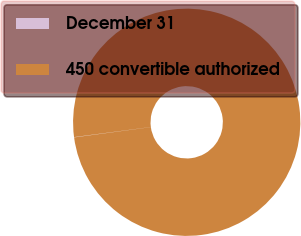<chart> <loc_0><loc_0><loc_500><loc_500><pie_chart><fcel>December 31<fcel>450 convertible authorized<nl><fcel>0.04%<fcel>99.96%<nl></chart> 